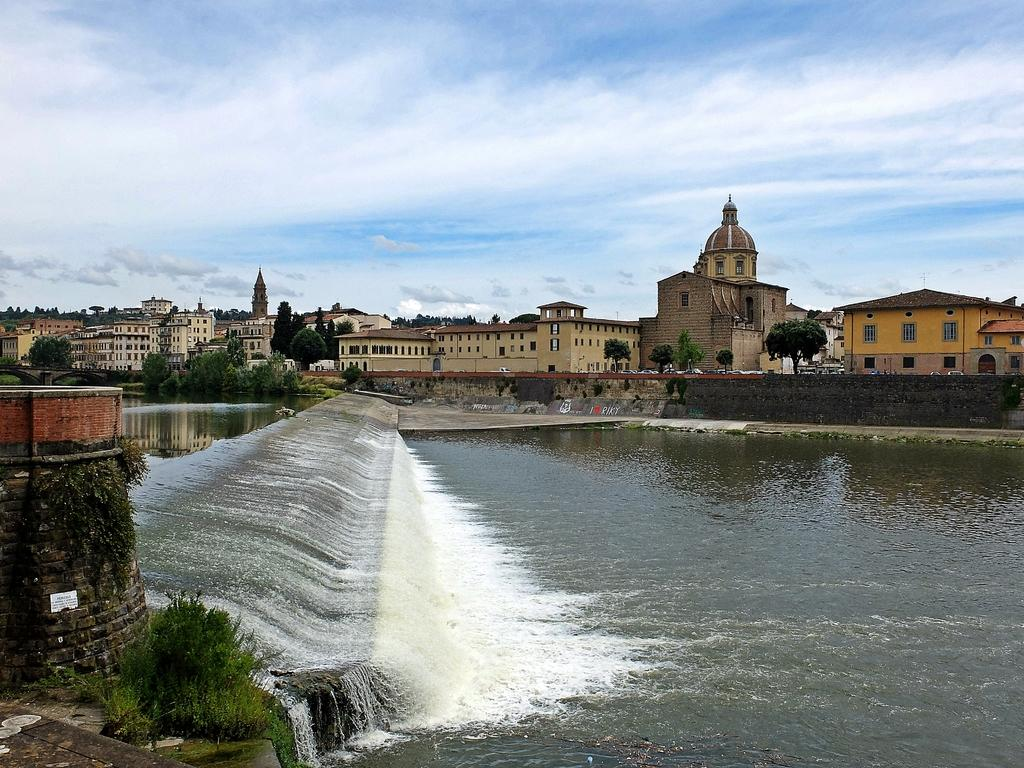What is the primary element visible in the image? There is water in the image. What other natural elements can be seen in the image? There are plants, trees, and the sky visible in the image. Are there any man-made structures present in the image? Yes, there are buildings and a wall in the image. What is the condition of the sky in the image? The sky is visible in the background of the image, and there are clouds present. What type of rock can be seen in the image? There is no rock present in the image. How does the water range in temperature throughout the image? The image does not provide information about the temperature of the water, so it cannot be determined. 